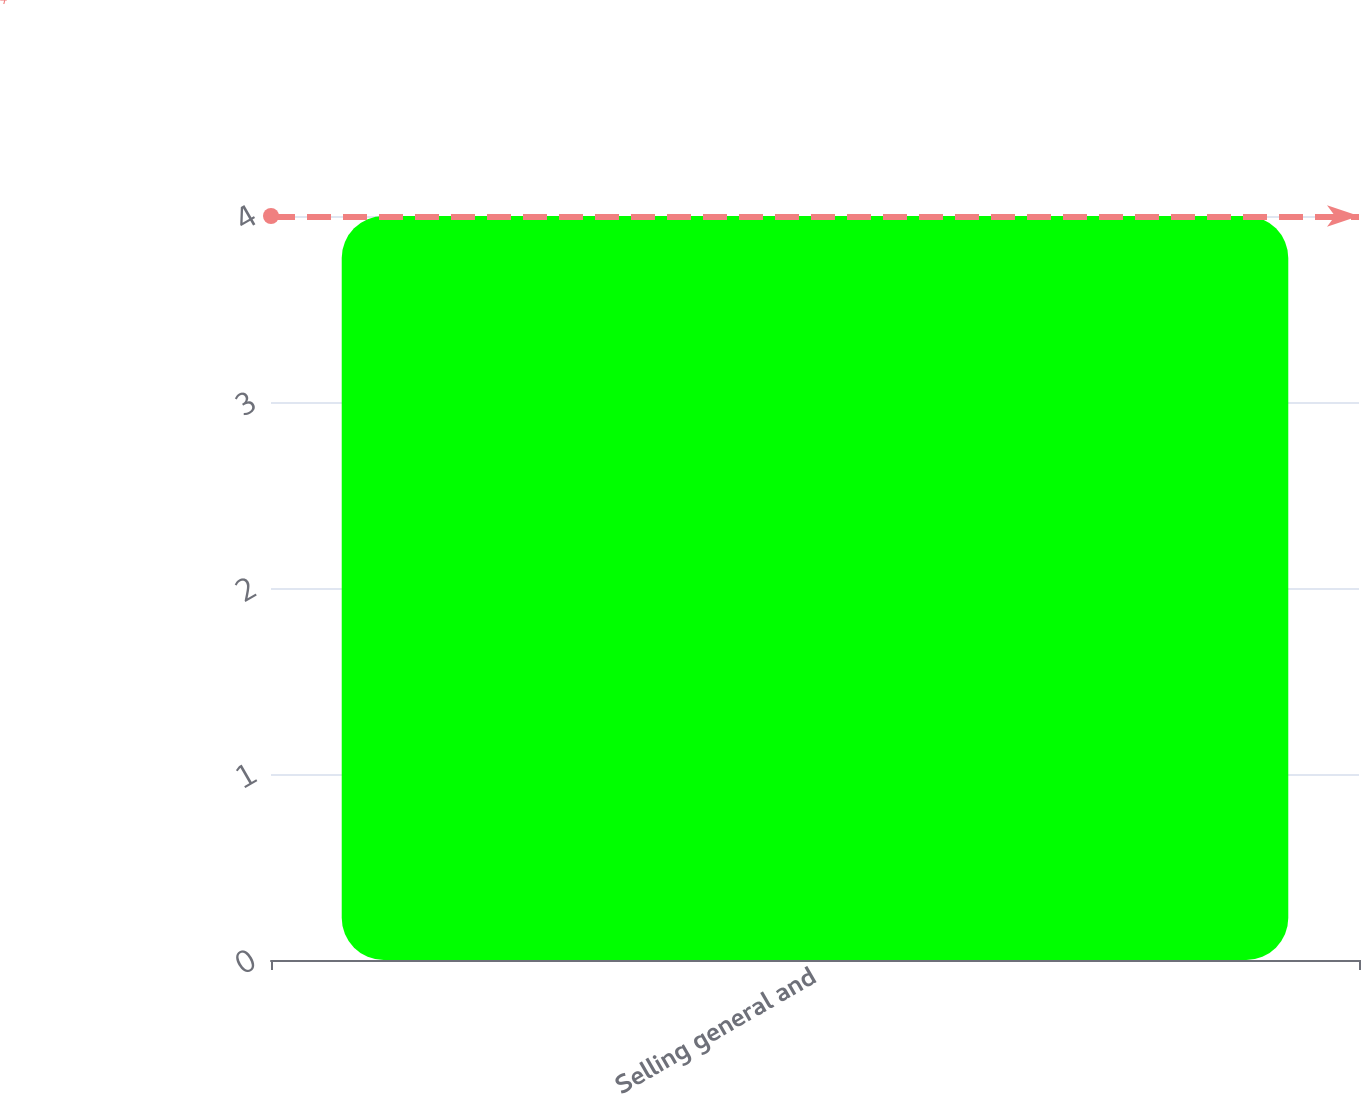Convert chart to OTSL. <chart><loc_0><loc_0><loc_500><loc_500><bar_chart><fcel>Selling general and<nl><fcel>4<nl></chart> 